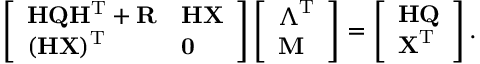Convert formula to latex. <formula><loc_0><loc_0><loc_500><loc_500>\left [ \begin{array} { l l } { H Q H ^ { T } + R } & { H X } \\ { ( H X ) ^ { T } } & { 0 } \end{array} \right ] \left [ \begin{array} { l } { \Lambda ^ { T } } \\ { M } \end{array} \right ] = \left [ \begin{array} { l } { H Q } \\ { X ^ { T } } \end{array} \right ] .</formula> 